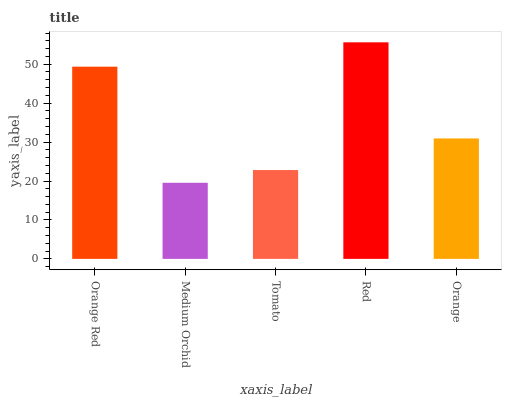Is Medium Orchid the minimum?
Answer yes or no. Yes. Is Red the maximum?
Answer yes or no. Yes. Is Tomato the minimum?
Answer yes or no. No. Is Tomato the maximum?
Answer yes or no. No. Is Tomato greater than Medium Orchid?
Answer yes or no. Yes. Is Medium Orchid less than Tomato?
Answer yes or no. Yes. Is Medium Orchid greater than Tomato?
Answer yes or no. No. Is Tomato less than Medium Orchid?
Answer yes or no. No. Is Orange the high median?
Answer yes or no. Yes. Is Orange the low median?
Answer yes or no. Yes. Is Medium Orchid the high median?
Answer yes or no. No. Is Tomato the low median?
Answer yes or no. No. 